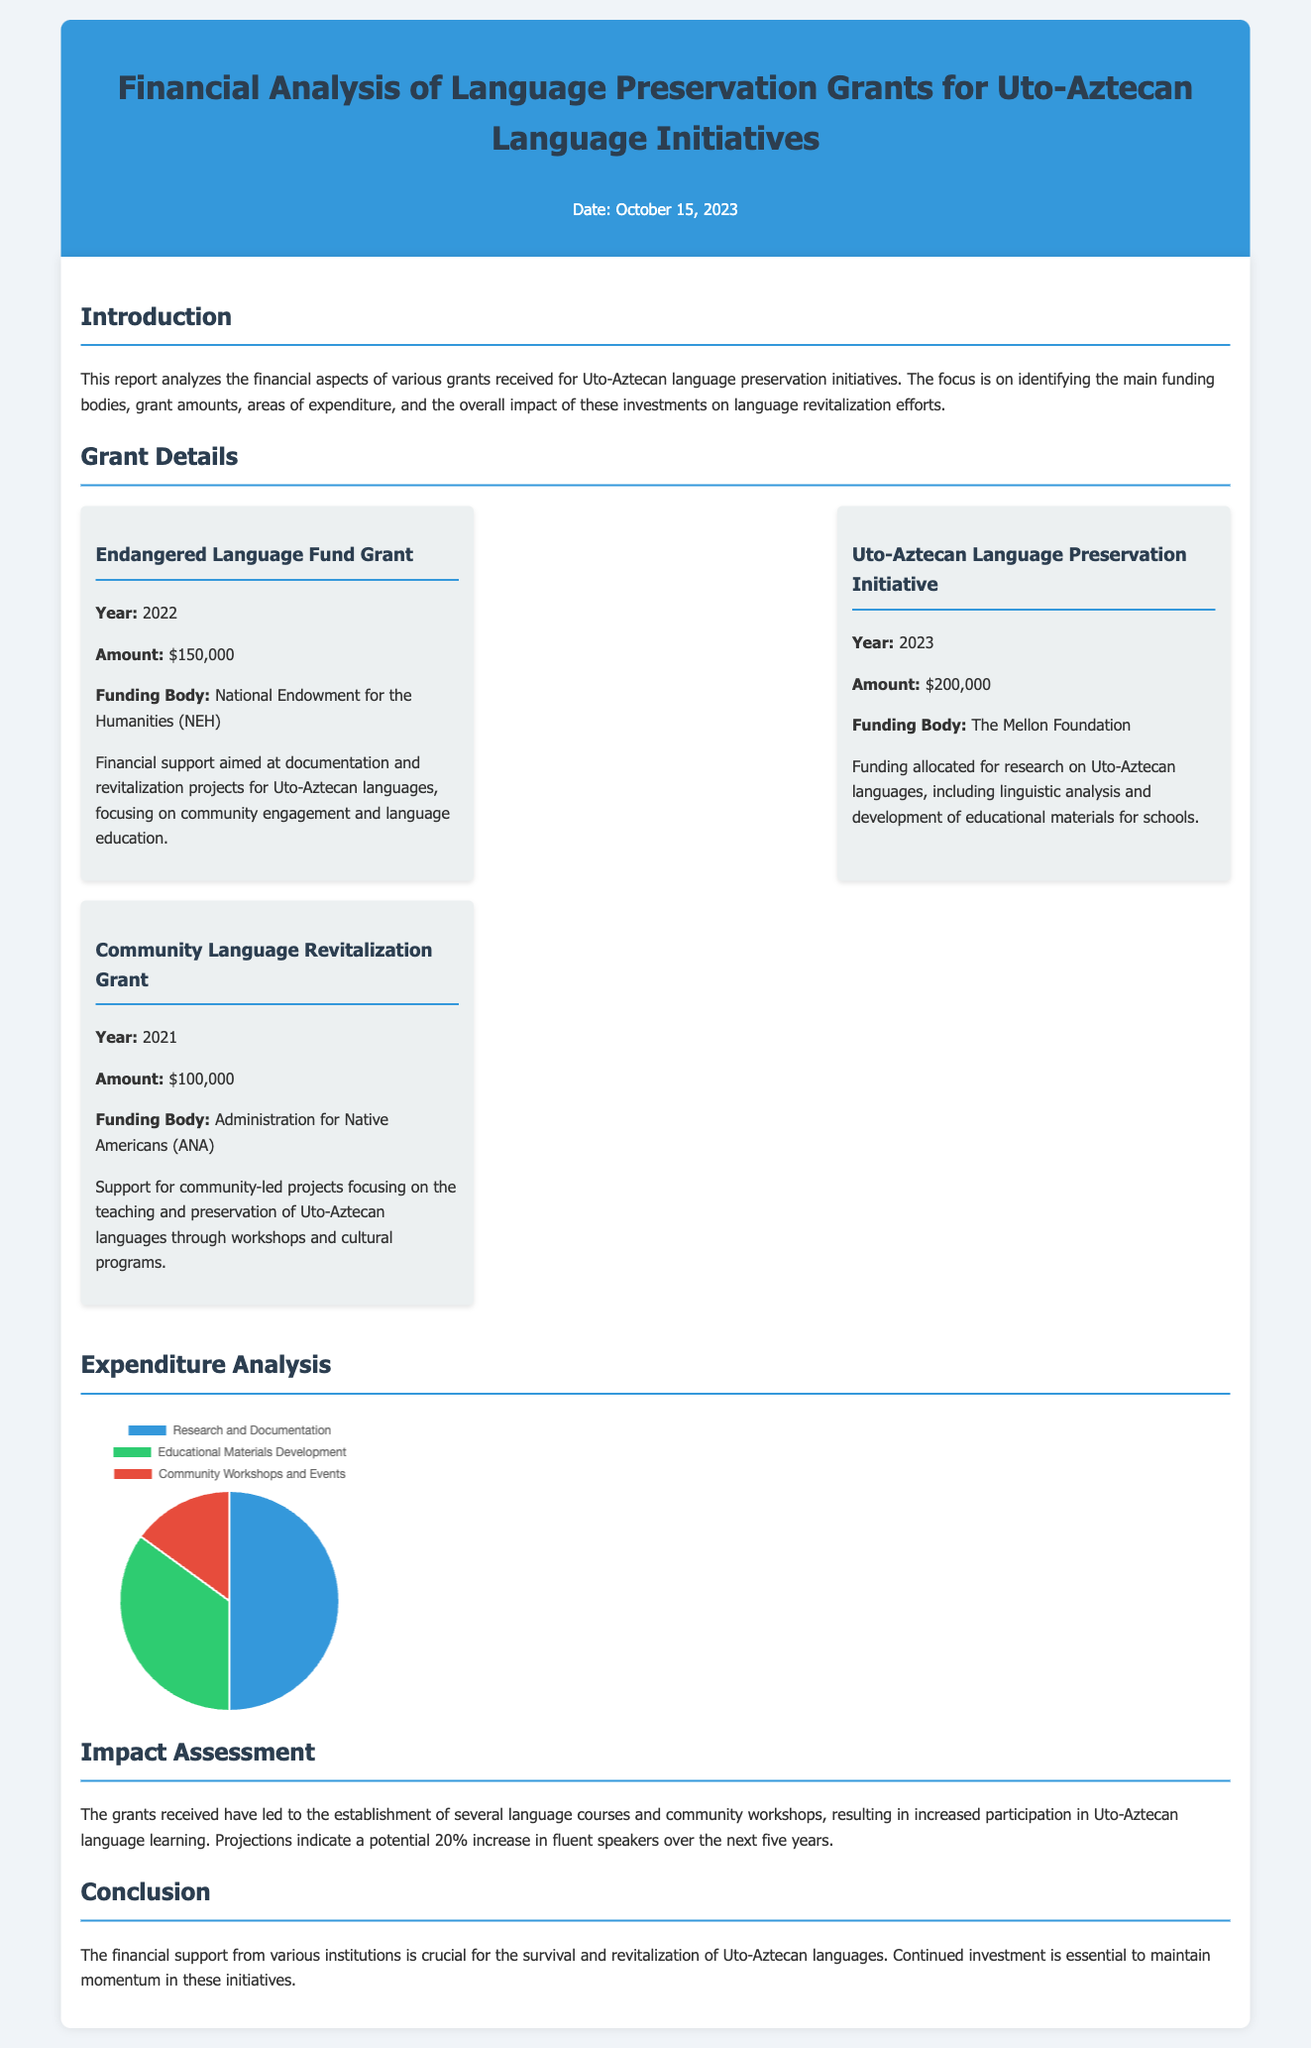what is the total amount of grants received? The total amount is the sum of all grant amounts listed in the document, which is $150,000 + $200,000 + $100,000 = $450,000.
Answer: $450,000 who is the funding body for the 2023 grant? The funding body for the 2023 grant is detailed in the grant details section.
Answer: The Mellon Foundation how many areas of expenditure are listed in the chart? The chart collects data on expenditure types across different categories outlined in the document.
Answer: 3 what was the focus of the Community Language Revitalization Grant? The focus is described in the details of the grant in terms of community engagement and preservation efforts.
Answer: Teaching and preservation how much funding was allocated for the 2022 grant? The amount allocated is clearly stated next to the respective grant's details.
Answer: $150,000 what percentage of expenditures was allocated to research and documentation? The expenditure distribution is presented in the chart, with specific data points for each category.
Answer: 50 what is the projected increase in fluent speakers over the next five years? The impact assessment section provides insights into the expected outcome of the grants received.
Answer: 20% which grant focuses on educational materials development? The details of each grant specify their main focus and objectives.
Answer: Uto-Aztecan Language Preservation Initiative who provided support for community-led projects? The donor organization for community projects is listed in the relevant grant details.
Answer: Administration for Native Americans 